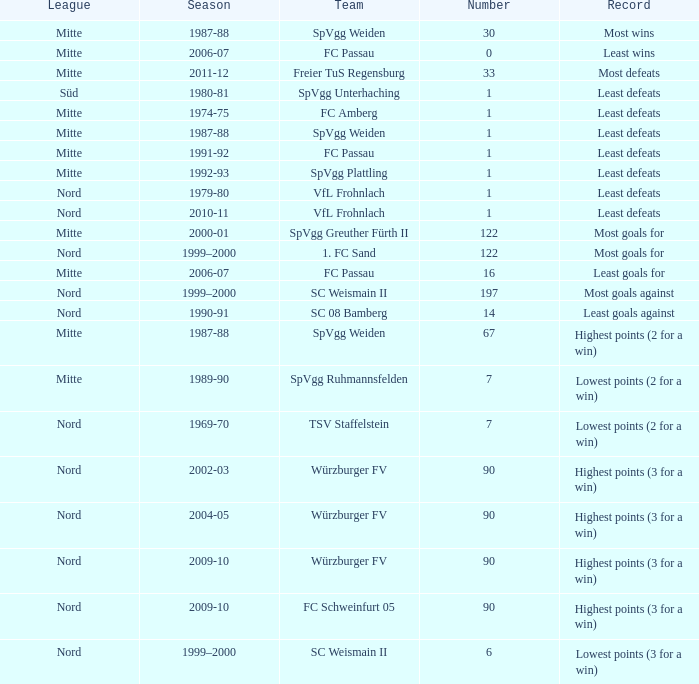What season has a number less than 90, Mitte as the league and spvgg ruhmannsfelden as the team? 1989-90. 